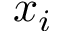<formula> <loc_0><loc_0><loc_500><loc_500>x _ { i }</formula> 